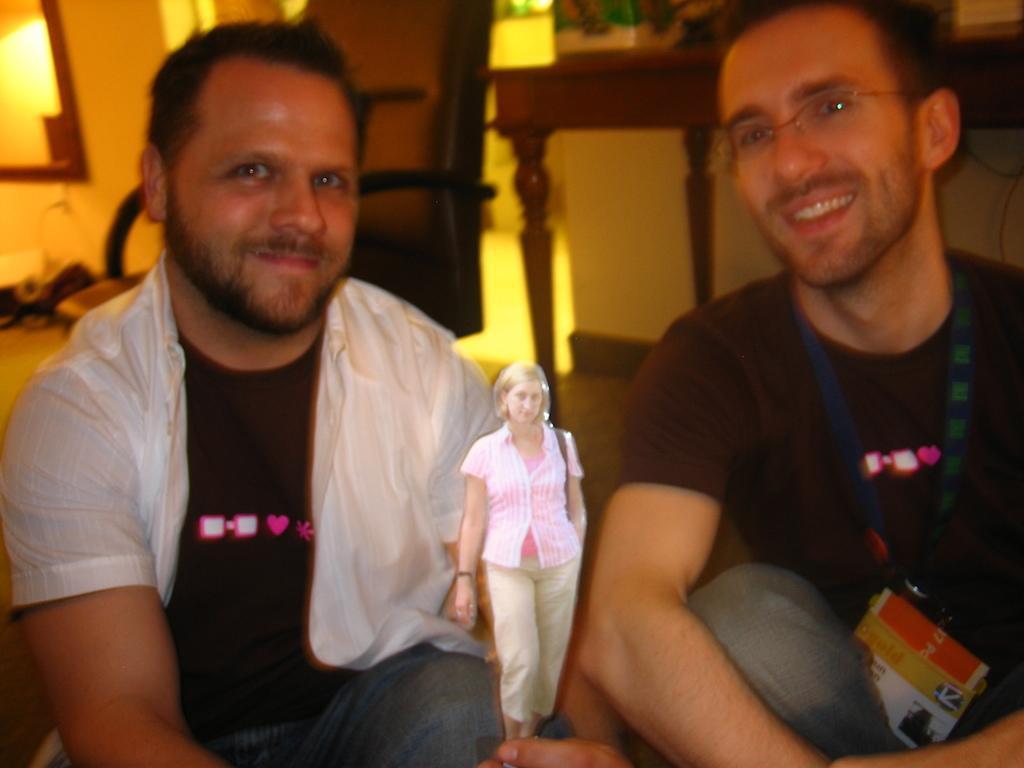Could you give a brief overview of what you see in this image? In the image we can see there are men sitting on the ground and there is a woman standing. Behind there is chair and table on the ground. Background of the image is little blurred. 